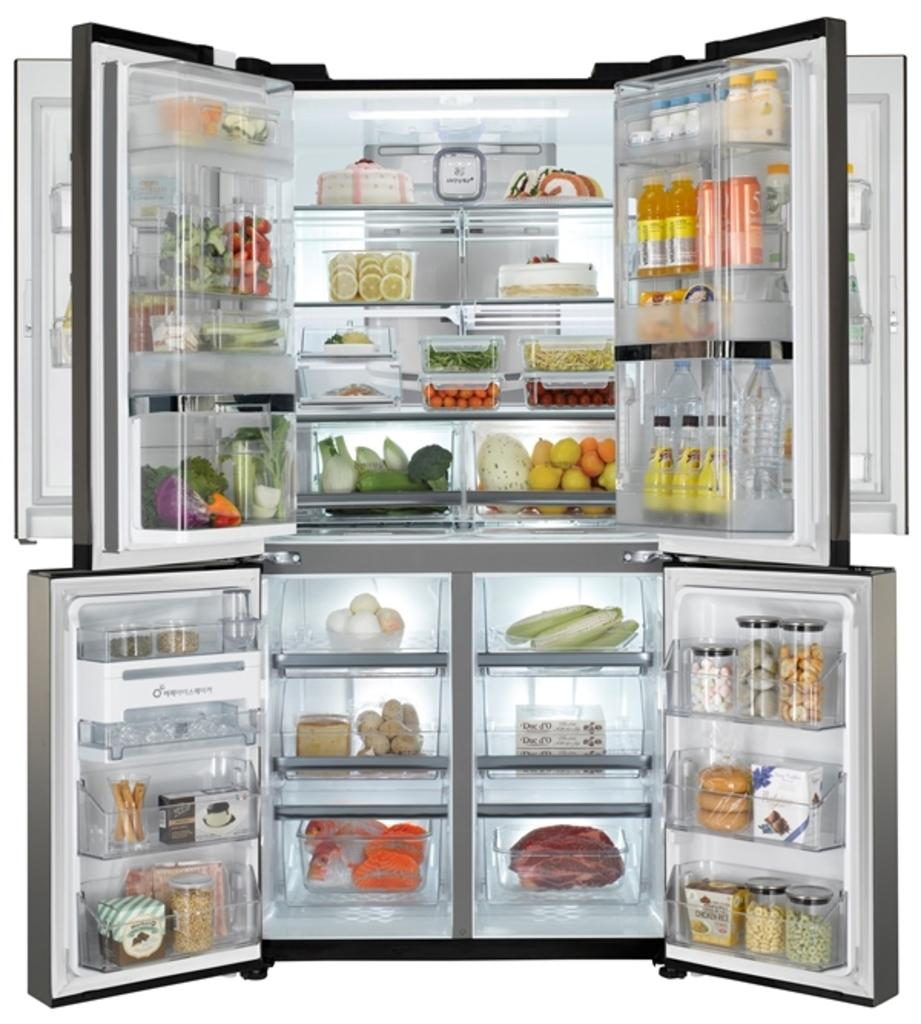What is the state of the fridge in the image? The image shows a fridge that is opened. What types of food can be seen inside the fridge? There are vegetables, fruits, meat, juices, water bottles, bread, eggs, dates, and pastries inside the fridge. How many different types of food items are visible in the fridge? There are 10 different types of food items visible in the fridge. What type of mist can be seen coming out of the fridge in the image? There is no mist visible coming out of the fridge in the image. What type of stamp is on the bread inside the fridge? There is no stamp visible on the bread inside the fridge. 